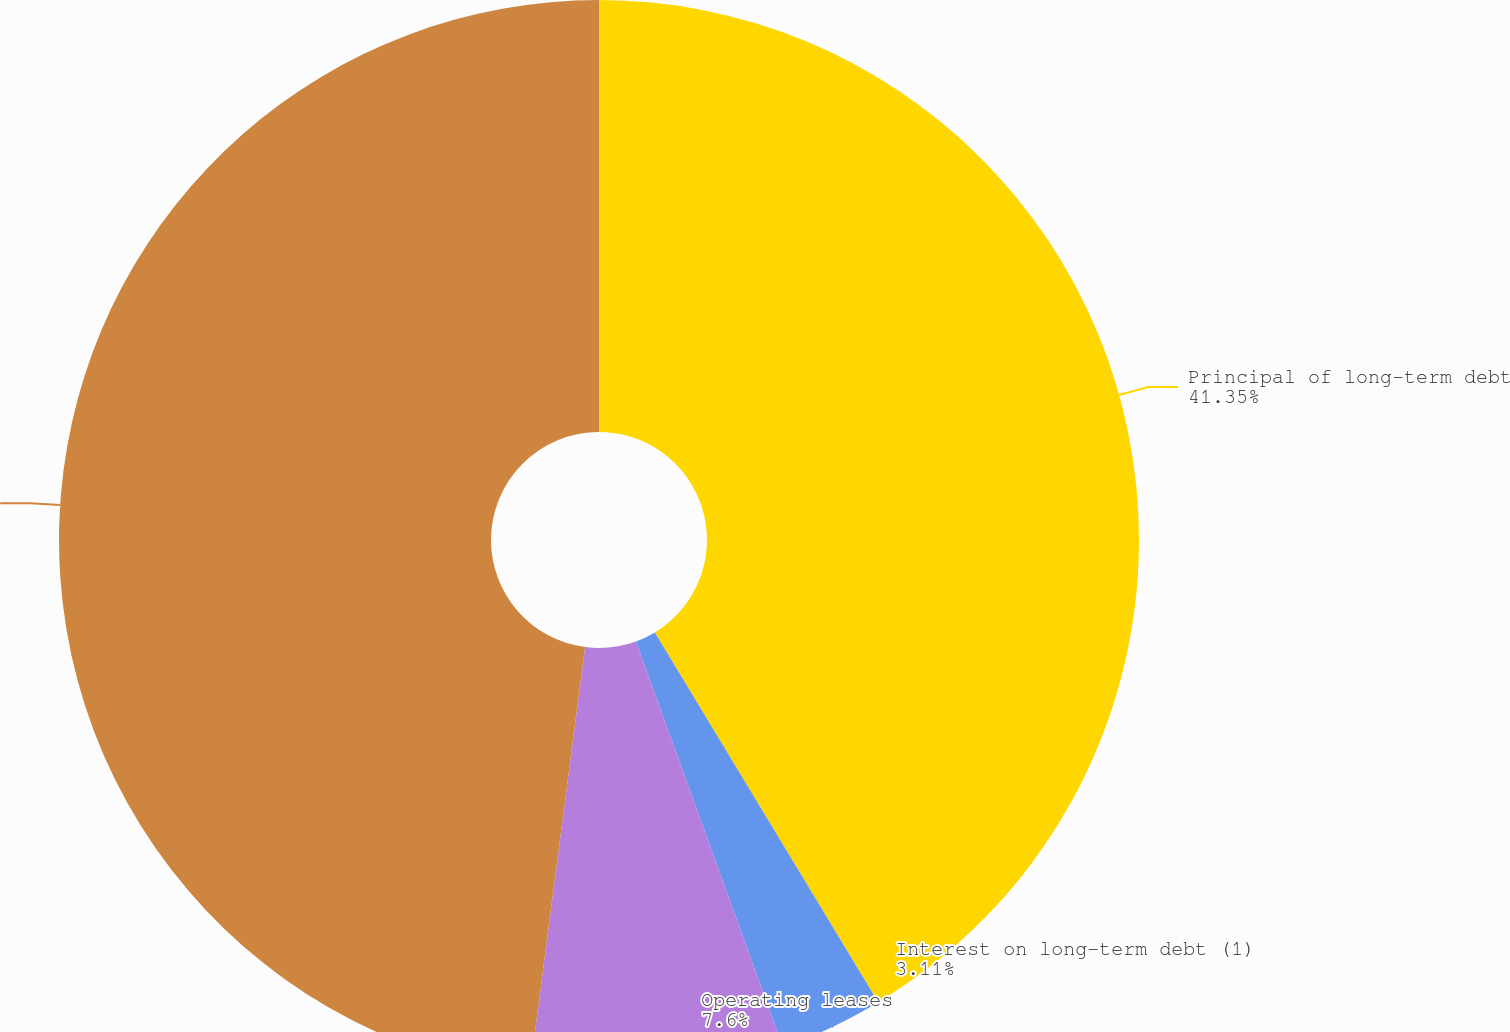<chart> <loc_0><loc_0><loc_500><loc_500><pie_chart><fcel>Principal of long-term debt<fcel>Interest on long-term debt (1)<fcel>Operating leases<fcel>Total<nl><fcel>41.35%<fcel>3.11%<fcel>7.6%<fcel>47.94%<nl></chart> 